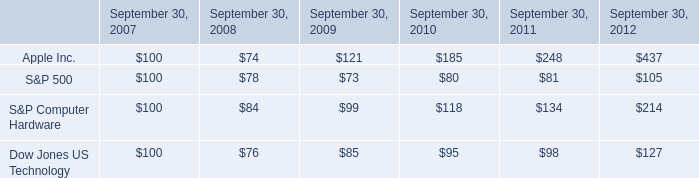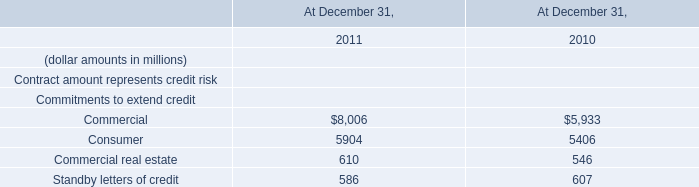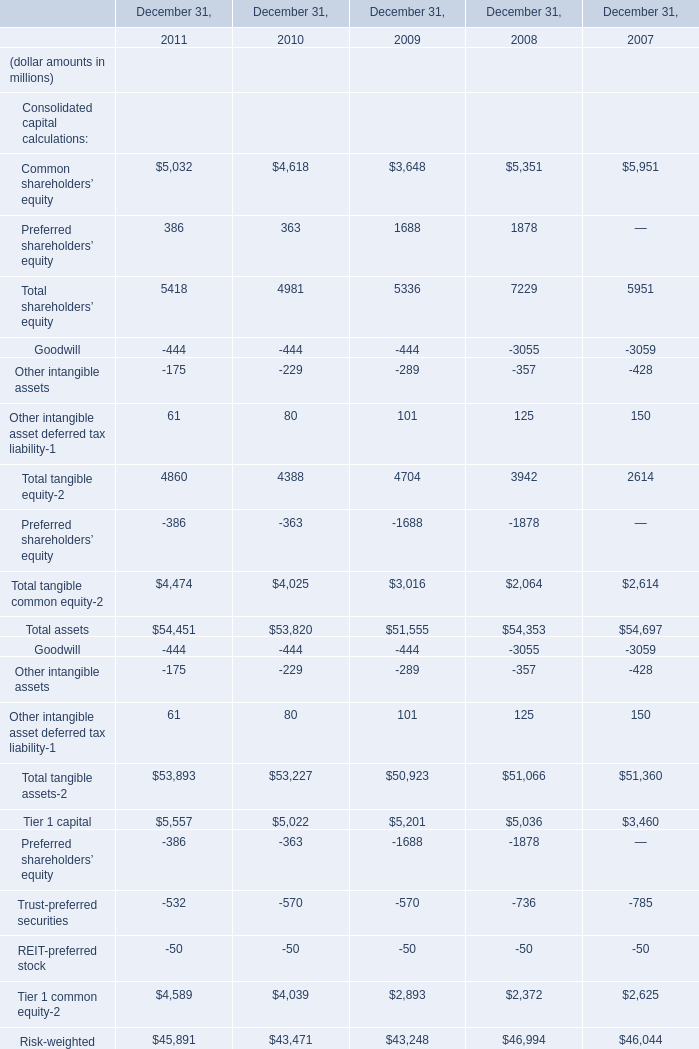In the year with largest amount of Total tangible equity-2, what's the increasing rate of Total tangible common equity-2? (in %) 
Computations: ((4474 - 4025) / 4025)
Answer: 0.11155. 